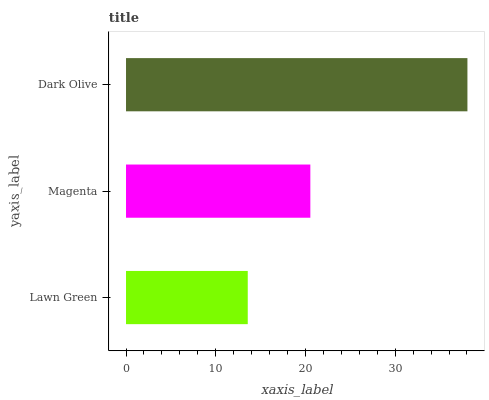Is Lawn Green the minimum?
Answer yes or no. Yes. Is Dark Olive the maximum?
Answer yes or no. Yes. Is Magenta the minimum?
Answer yes or no. No. Is Magenta the maximum?
Answer yes or no. No. Is Magenta greater than Lawn Green?
Answer yes or no. Yes. Is Lawn Green less than Magenta?
Answer yes or no. Yes. Is Lawn Green greater than Magenta?
Answer yes or no. No. Is Magenta less than Lawn Green?
Answer yes or no. No. Is Magenta the high median?
Answer yes or no. Yes. Is Magenta the low median?
Answer yes or no. Yes. Is Dark Olive the high median?
Answer yes or no. No. Is Dark Olive the low median?
Answer yes or no. No. 